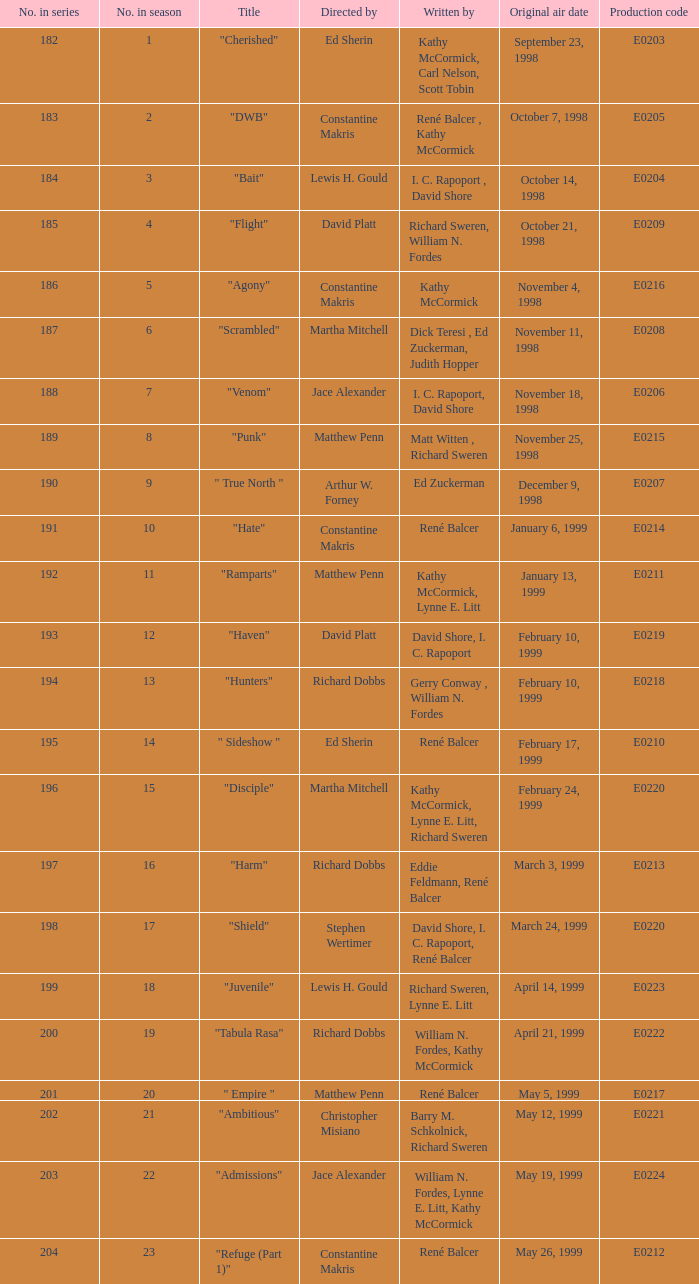Who composed the episode that first broadcasted on january 13, 1999? Kathy McCormick, Lynne E. Litt. 